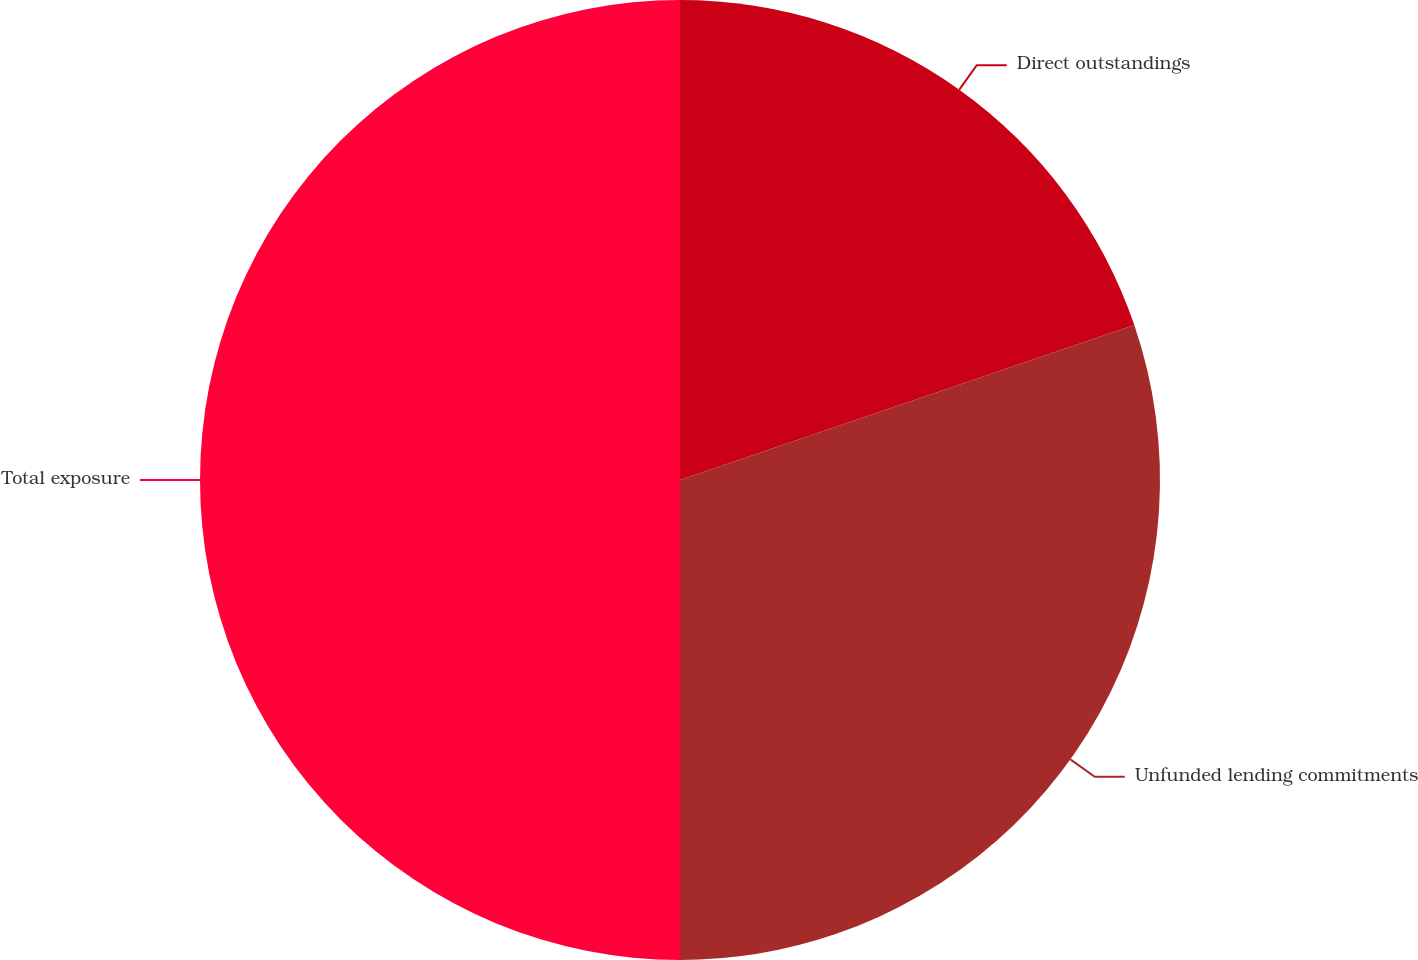Convert chart to OTSL. <chart><loc_0><loc_0><loc_500><loc_500><pie_chart><fcel>Direct outstandings<fcel>Unfunded lending commitments<fcel>Total exposure<nl><fcel>19.77%<fcel>30.23%<fcel>50.0%<nl></chart> 